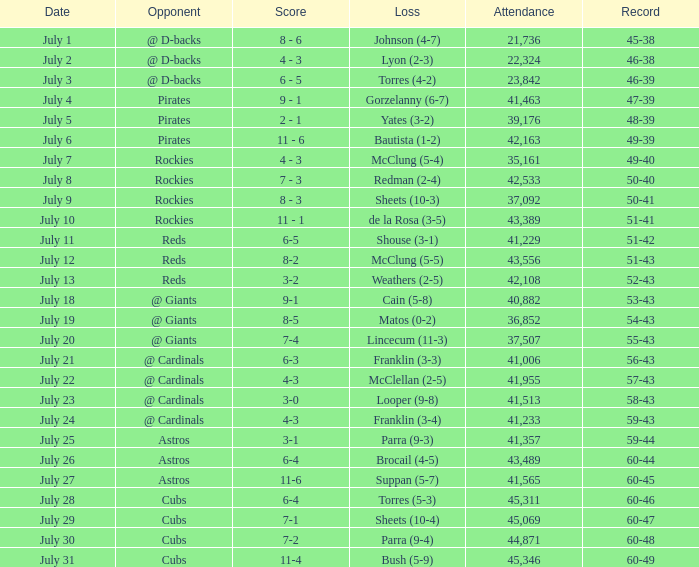How many people attended the game in which yates was defeated with a 3-2 result? 39176.0. 